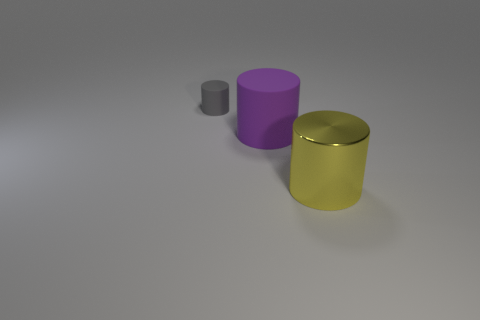Are the small gray thing that is behind the purple object and the yellow object made of the same material?
Make the answer very short. No. There is a thing that is behind the rubber object that is in front of the gray thing; what color is it?
Ensure brevity in your answer.  Gray. There is a big yellow object that is the same shape as the tiny rubber object; what is it made of?
Offer a terse response. Metal. What color is the rubber thing that is on the right side of the thing to the left of the matte cylinder in front of the gray rubber cylinder?
Provide a short and direct response. Purple. What number of objects are either large yellow cylinders or gray rubber objects?
Keep it short and to the point. 2. How many large yellow metallic things are the same shape as the tiny thing?
Your answer should be very brief. 1. Does the large purple thing have the same material as the thing that is left of the big purple rubber cylinder?
Ensure brevity in your answer.  Yes. There is another purple object that is the same material as the small thing; what is its size?
Your response must be concise. Large. There is a matte object that is right of the gray rubber object; how big is it?
Provide a succinct answer. Large. How many yellow metallic things have the same size as the purple cylinder?
Offer a terse response. 1. 